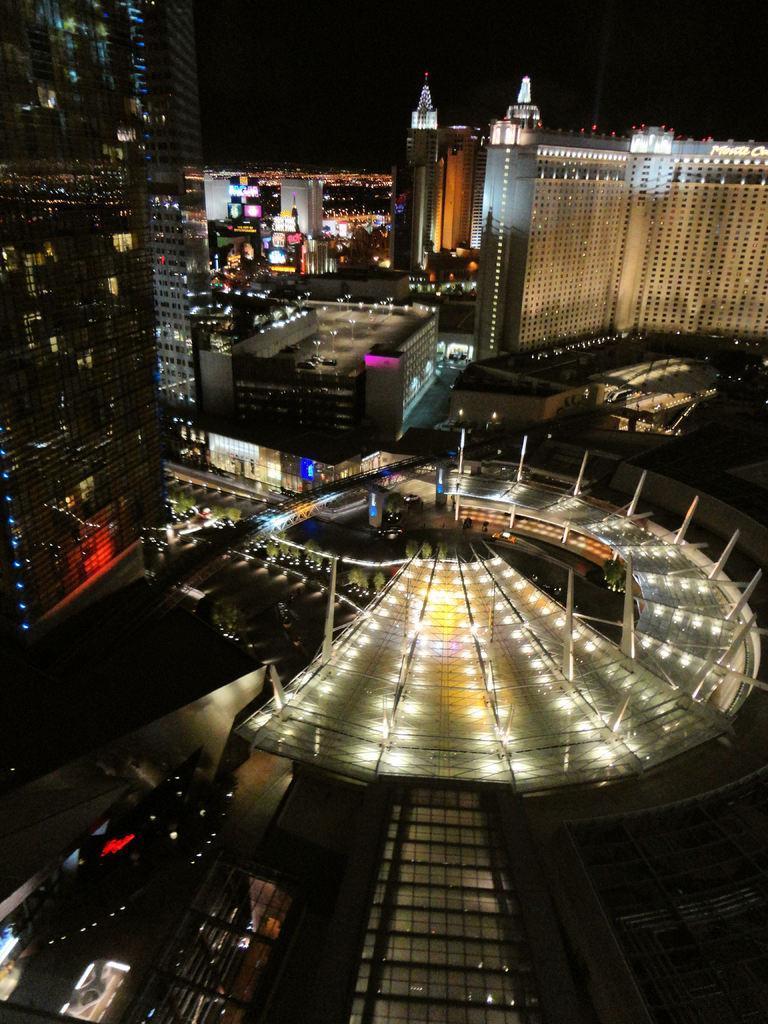Describe this image in one or two sentences. In this image there are many buildings with lights. In the background it is dark. 